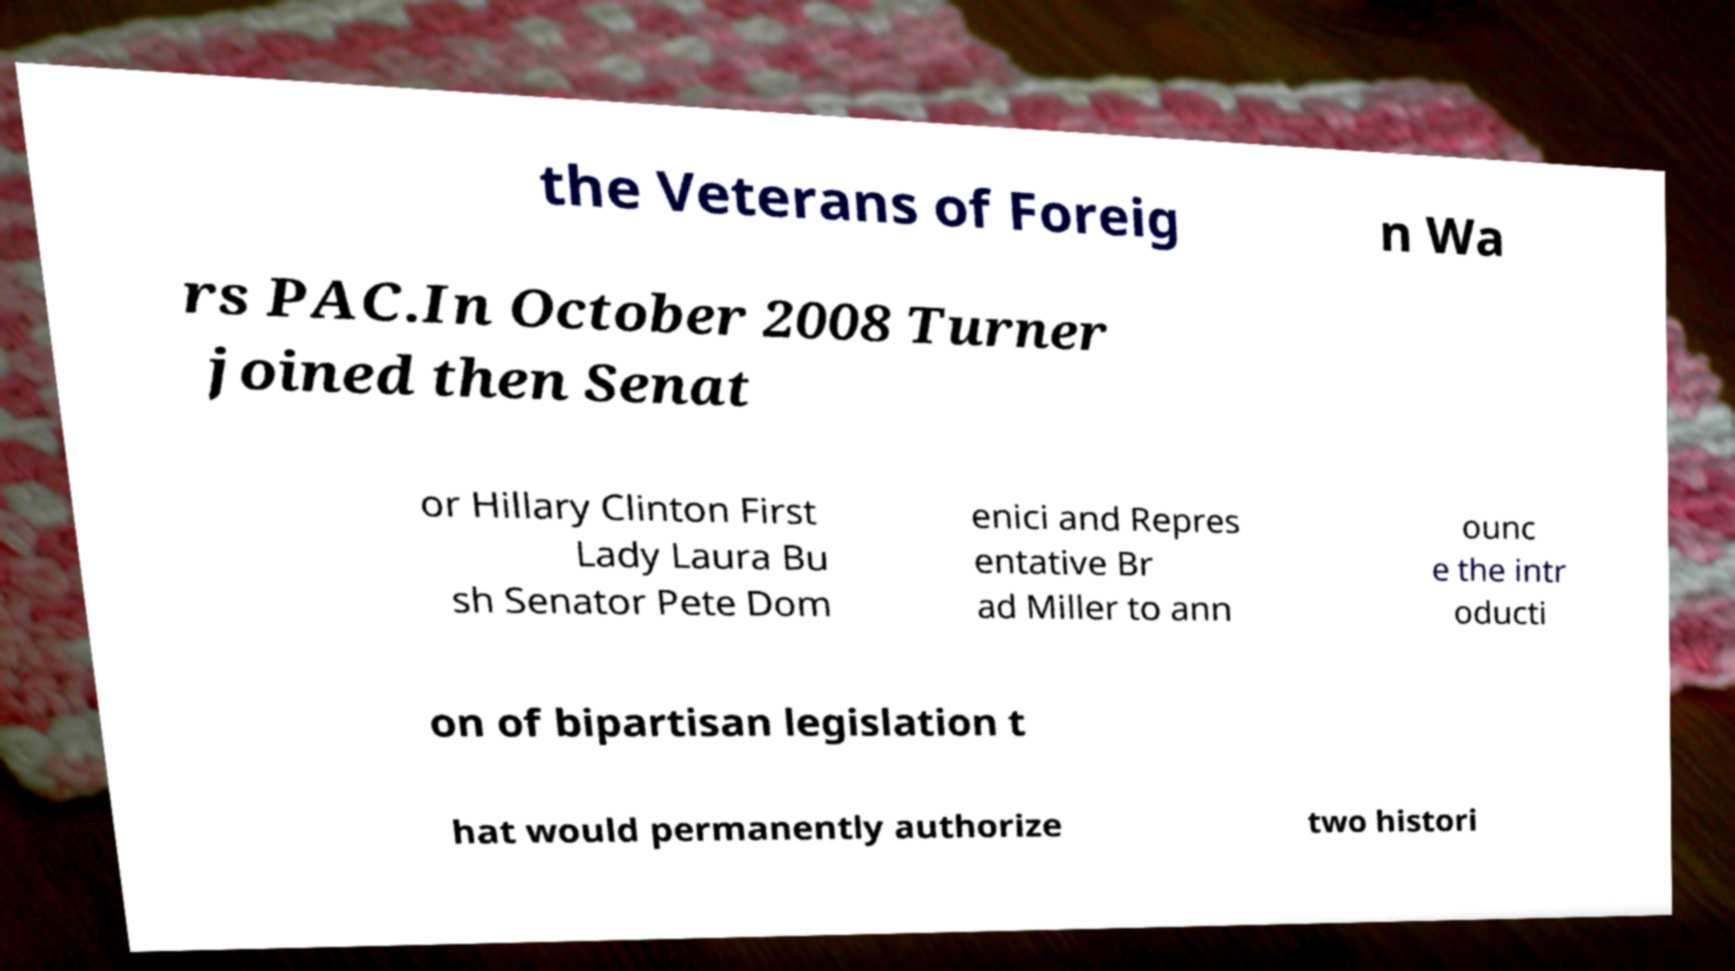Please identify and transcribe the text found in this image. the Veterans of Foreig n Wa rs PAC.In October 2008 Turner joined then Senat or Hillary Clinton First Lady Laura Bu sh Senator Pete Dom enici and Repres entative Br ad Miller to ann ounc e the intr oducti on of bipartisan legislation t hat would permanently authorize two histori 